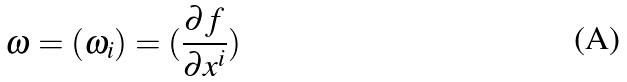<formula> <loc_0><loc_0><loc_500><loc_500>\omega = ( \omega _ { i } ) = ( \frac { \partial f } { \partial x ^ { i } } )</formula> 